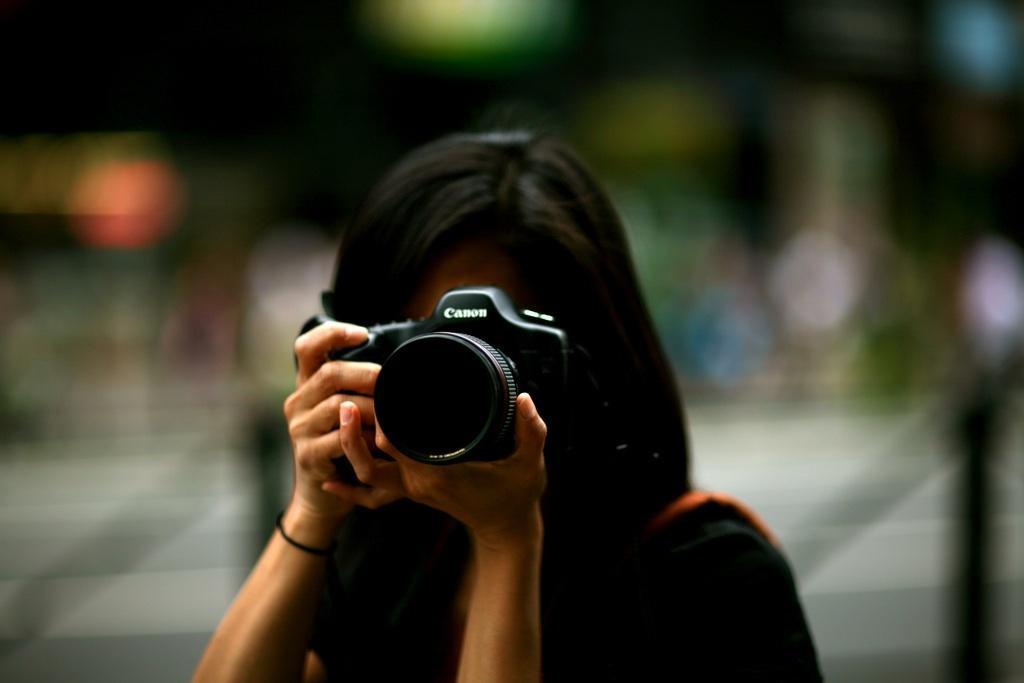Describe this image in one or two sentences. In this picture, There is a woman standing in the middle she is holding a camera which is in black color and she is taking a picture. 